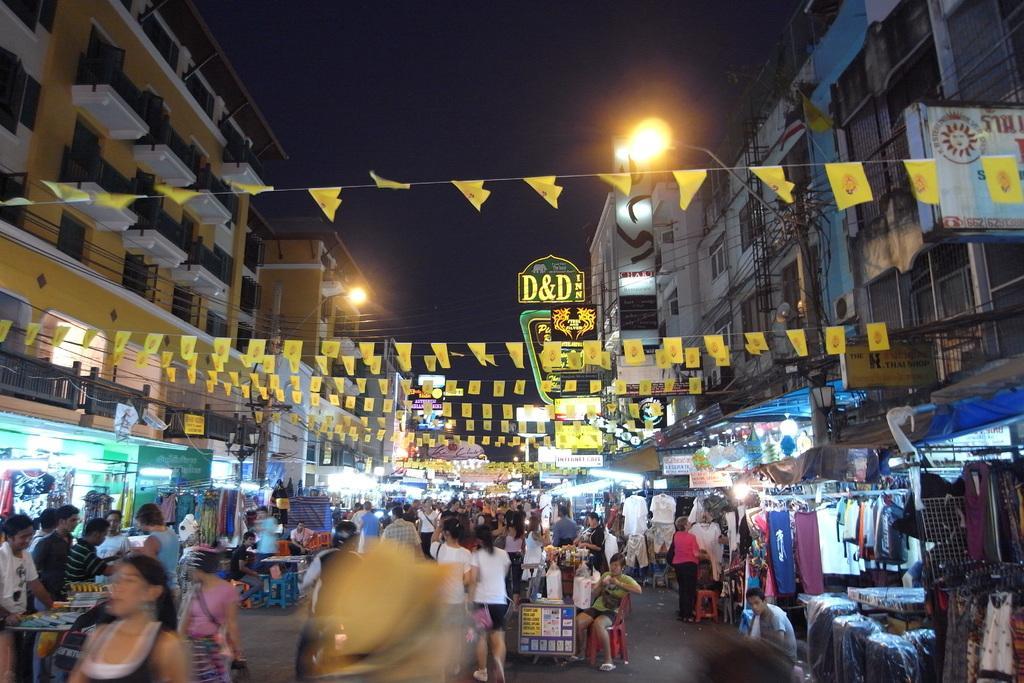Can you describe this image briefly? In this image we can see a group of persons, buildings, wires and banners. On both sides of the image we can see the stalls. On the buildings we can see few hoardings. We can see street poles with lights. 